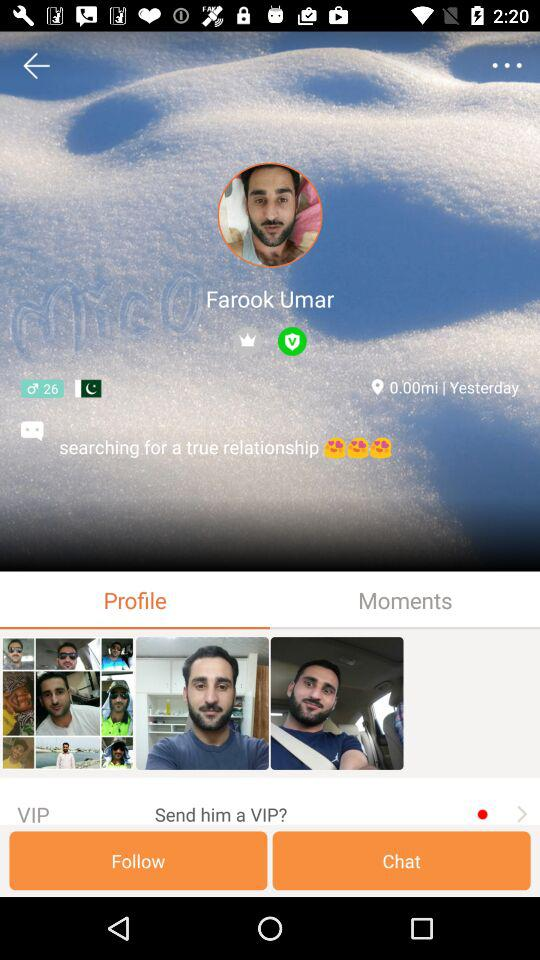What is the age of Farook? Farook is 26 years old. 